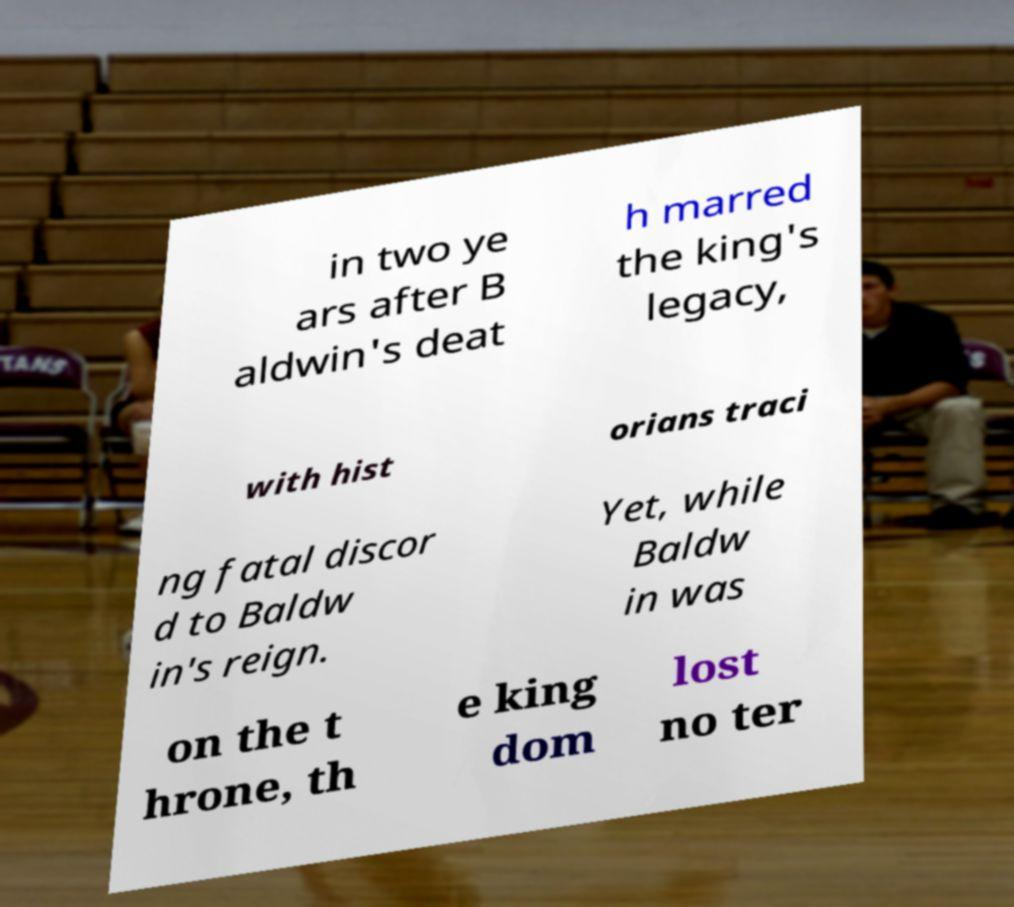Could you extract and type out the text from this image? in two ye ars after B aldwin's deat h marred the king's legacy, with hist orians traci ng fatal discor d to Baldw in's reign. Yet, while Baldw in was on the t hrone, th e king dom lost no ter 